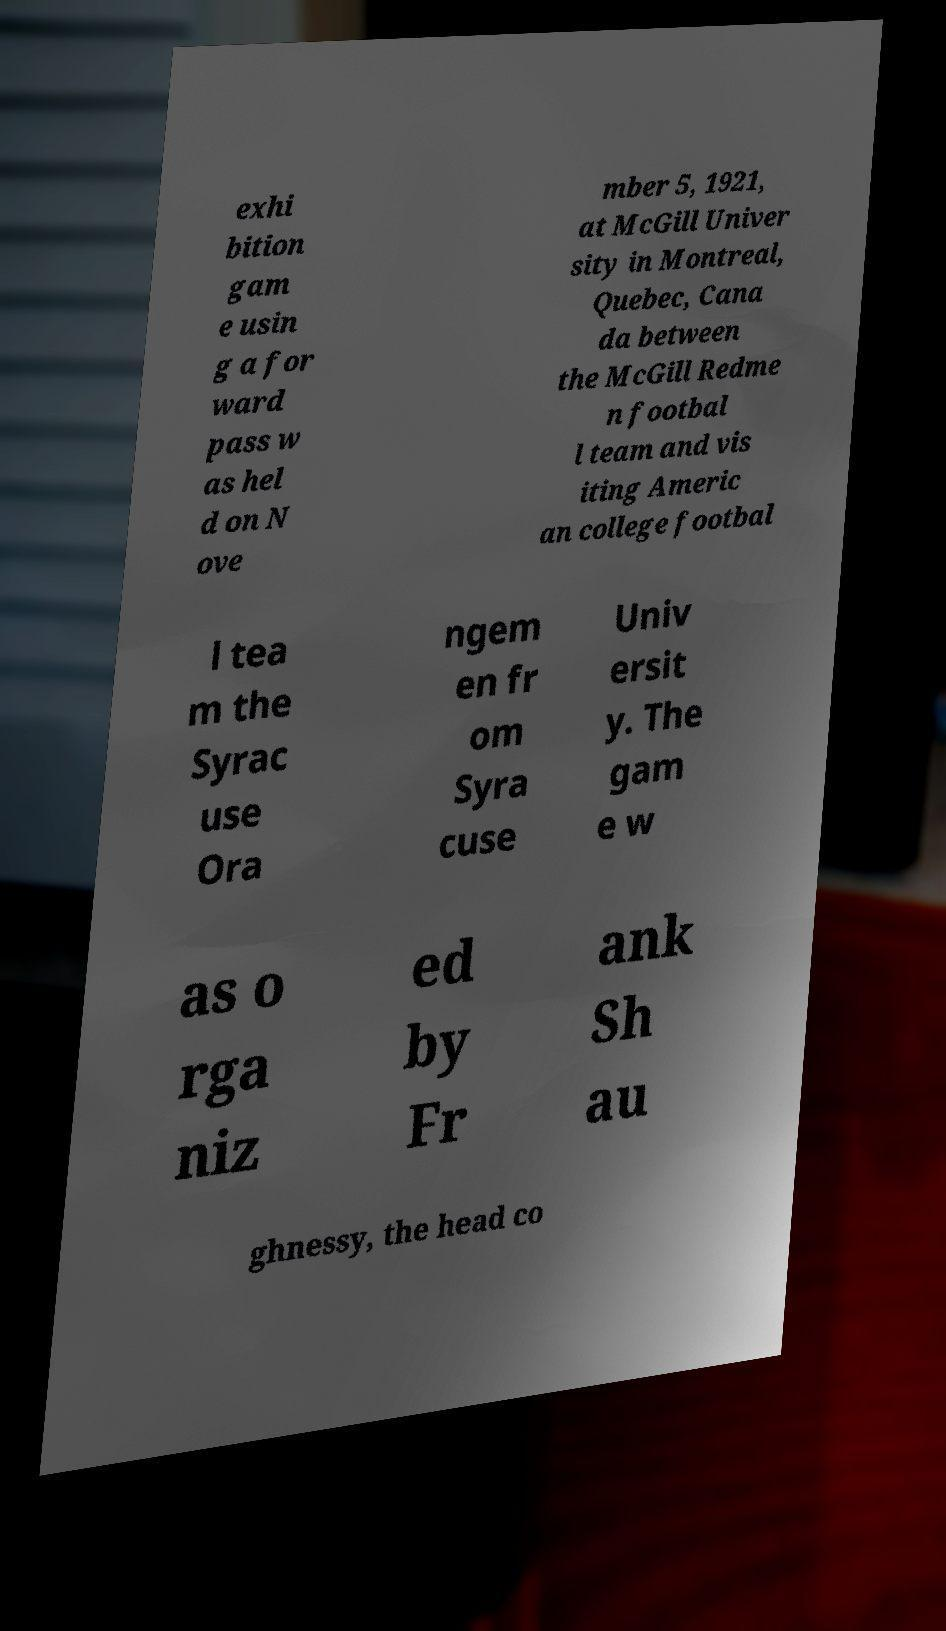What messages or text are displayed in this image? I need them in a readable, typed format. exhi bition gam e usin g a for ward pass w as hel d on N ove mber 5, 1921, at McGill Univer sity in Montreal, Quebec, Cana da between the McGill Redme n footbal l team and vis iting Americ an college footbal l tea m the Syrac use Ora ngem en fr om Syra cuse Univ ersit y. The gam e w as o rga niz ed by Fr ank Sh au ghnessy, the head co 